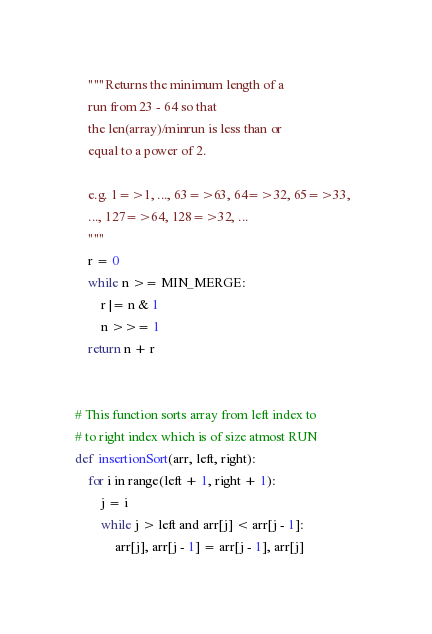Convert code to text. <code><loc_0><loc_0><loc_500><loc_500><_Python_>    """Returns the minimum length of a  
    run from 23 - 64 so that 
    the len(array)/minrun is less than or  
    equal to a power of 2. 
  
    e.g. 1=>1, ..., 63=>63, 64=>32, 65=>33,  
    ..., 127=>64, 128=>32, ... 
    """
    r = 0
    while n >= MIN_MERGE: 
        r |= n & 1
        n >>= 1
    return n + r 
  
  
# This function sorts array from left index to 
# to right index which is of size atmost RUN 
def insertionSort(arr, left, right): 
    for i in range(left + 1, right + 1): 
        j = i 
        while j > left and arr[j] < arr[j - 1]: 
            arr[j], arr[j - 1] = arr[j - 1], arr[j] </code> 